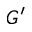Convert formula to latex. <formula><loc_0><loc_0><loc_500><loc_500>G ^ { \prime }</formula> 